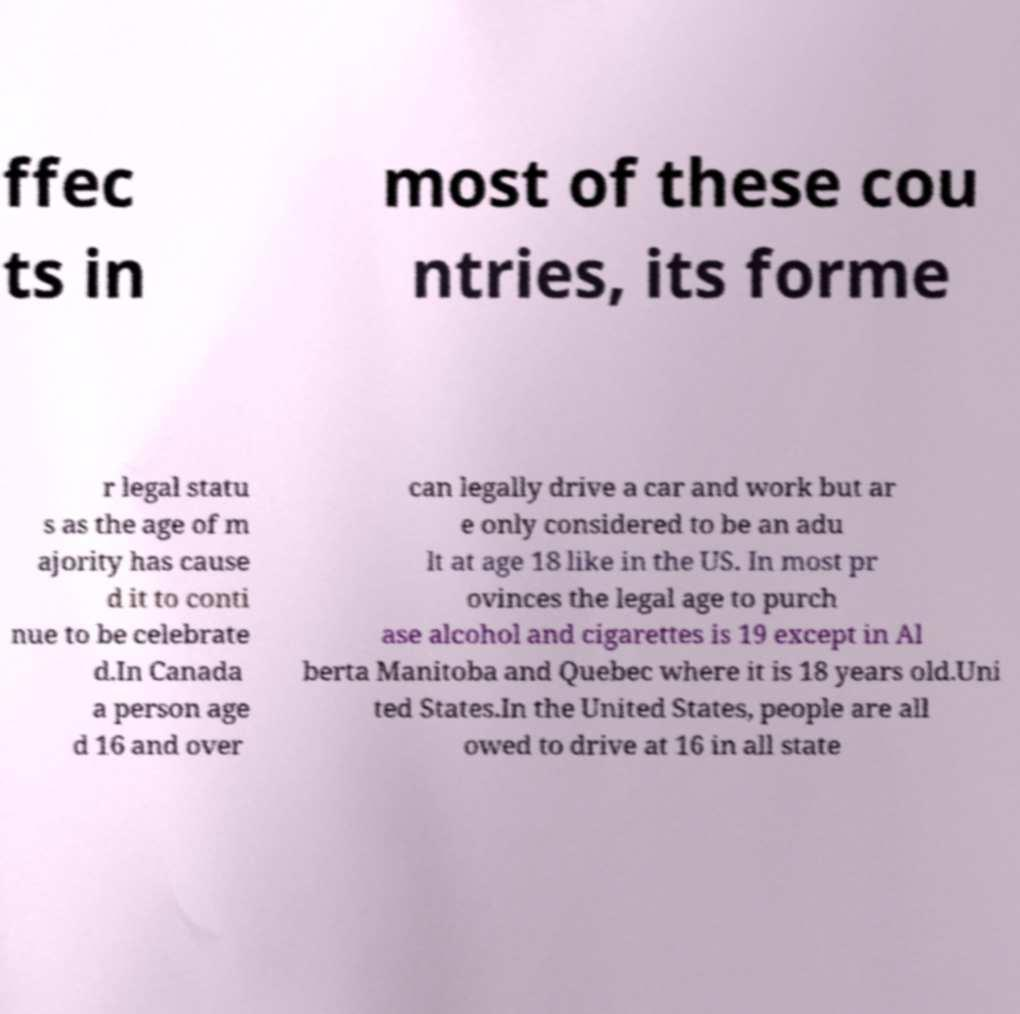For documentation purposes, I need the text within this image transcribed. Could you provide that? ffec ts in most of these cou ntries, its forme r legal statu s as the age of m ajority has cause d it to conti nue to be celebrate d.In Canada a person age d 16 and over can legally drive a car and work but ar e only considered to be an adu lt at age 18 like in the US. In most pr ovinces the legal age to purch ase alcohol and cigarettes is 19 except in Al berta Manitoba and Quebec where it is 18 years old.Uni ted States.In the United States, people are all owed to drive at 16 in all state 